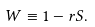Convert formula to latex. <formula><loc_0><loc_0><loc_500><loc_500>W \equiv 1 - r S .</formula> 